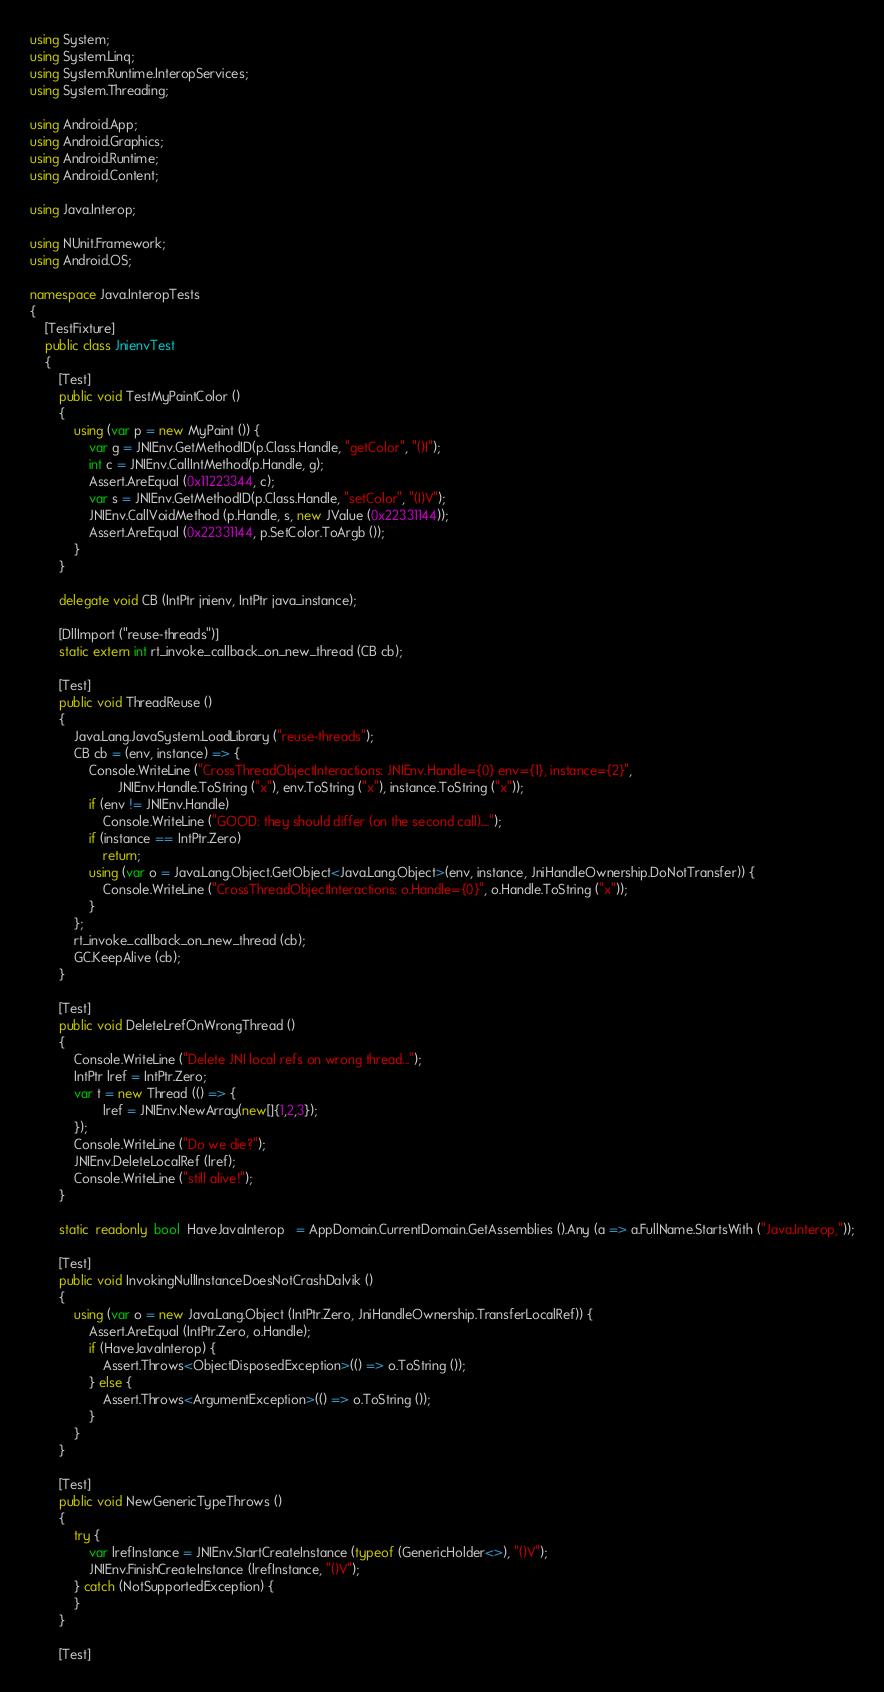<code> <loc_0><loc_0><loc_500><loc_500><_C#_>using System;
using System.Linq;
using System.Runtime.InteropServices;
using System.Threading;

using Android.App;
using Android.Graphics;
using Android.Runtime;
using Android.Content;

using Java.Interop;

using NUnit.Framework;
using Android.OS;

namespace Java.InteropTests
{
	[TestFixture]
	public class JnienvTest
	{
		[Test]
		public void TestMyPaintColor ()
		{
			using (var p = new MyPaint ()) {
				var g = JNIEnv.GetMethodID(p.Class.Handle, "getColor", "()I");
				int c = JNIEnv.CallIntMethod(p.Handle, g);
				Assert.AreEqual (0x11223344, c);
				var s = JNIEnv.GetMethodID(p.Class.Handle, "setColor", "(I)V");
				JNIEnv.CallVoidMethod (p.Handle, s, new JValue (0x22331144));
				Assert.AreEqual (0x22331144, p.SetColor.ToArgb ());
			}
		}

		delegate void CB (IntPtr jnienv, IntPtr java_instance);

		[DllImport ("reuse-threads")]
		static extern int rt_invoke_callback_on_new_thread (CB cb);

		[Test]
		public void ThreadReuse ()
		{
			Java.Lang.JavaSystem.LoadLibrary ("reuse-threads");
			CB cb = (env, instance) => {
				Console.WriteLine ("CrossThreadObjectInteractions: JNIEnv.Handle={0} env={1}, instance={2}",
						JNIEnv.Handle.ToString ("x"), env.ToString ("x"), instance.ToString ("x"));
				if (env != JNIEnv.Handle)
					Console.WriteLine ("GOOD: they should differ (on the second call)....");
				if (instance == IntPtr.Zero)
					return;
				using (var o = Java.Lang.Object.GetObject<Java.Lang.Object>(env, instance, JniHandleOwnership.DoNotTransfer)) {
					Console.WriteLine ("CrossThreadObjectInteractions: o.Handle={0}", o.Handle.ToString ("x"));
				}
			};
			rt_invoke_callback_on_new_thread (cb);
			GC.KeepAlive (cb);
		}

		[Test]
		public void DeleteLrefOnWrongThread ()
		{
			Console.WriteLine ("Delete JNI local refs on wrong thread...");
			IntPtr lref = IntPtr.Zero;
			var t = new Thread (() => {
					lref = JNIEnv.NewArray(new[]{1,2,3});
			});
			Console.WriteLine ("Do we die?");
			JNIEnv.DeleteLocalRef (lref);
			Console.WriteLine ("still alive!");
		}

		static  readonly  bool  HaveJavaInterop   = AppDomain.CurrentDomain.GetAssemblies ().Any (a => a.FullName.StartsWith ("Java.Interop,"));

		[Test]
		public void InvokingNullInstanceDoesNotCrashDalvik ()
		{
			using (var o = new Java.Lang.Object (IntPtr.Zero, JniHandleOwnership.TransferLocalRef)) {
				Assert.AreEqual (IntPtr.Zero, o.Handle);
				if (HaveJavaInterop) {
					Assert.Throws<ObjectDisposedException>(() => o.ToString ());
				} else {
					Assert.Throws<ArgumentException>(() => o.ToString ());
				}
			}
		}

		[Test]
		public void NewGenericTypeThrows ()
		{
			try {
				var lrefInstance = JNIEnv.StartCreateInstance (typeof (GenericHolder<>), "()V");
				JNIEnv.FinishCreateInstance (lrefInstance, "()V");
			} catch (NotSupportedException) {
			}
		}

		[Test]</code> 